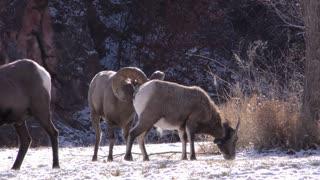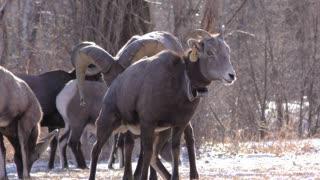The first image is the image on the left, the second image is the image on the right. Given the left and right images, does the statement "A long horn sheep is laying on the ground" hold true? Answer yes or no. No. The first image is the image on the left, the second image is the image on the right. Given the left and right images, does the statement "The are two mountain goats on the left image." hold true? Answer yes or no. No. 